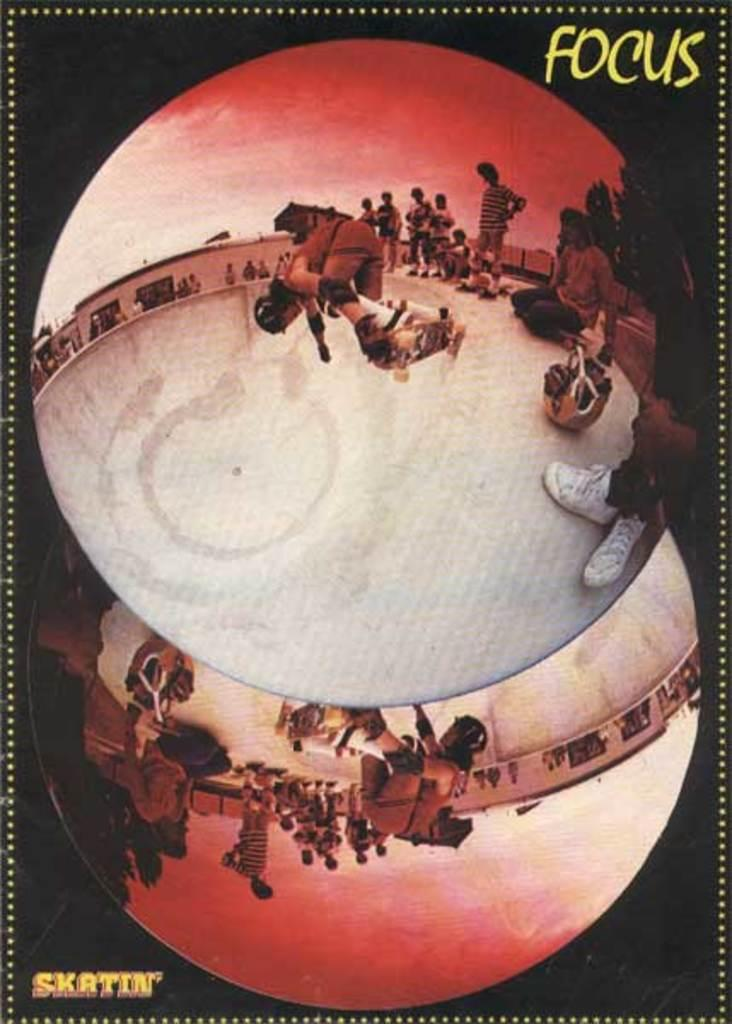<image>
Create a compact narrative representing the image presented. Two circle mirrors of a skate park with the word focus written in the top corner. 